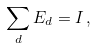Convert formula to latex. <formula><loc_0><loc_0><loc_500><loc_500>\sum _ { d } E _ { d } = I \, ,</formula> 